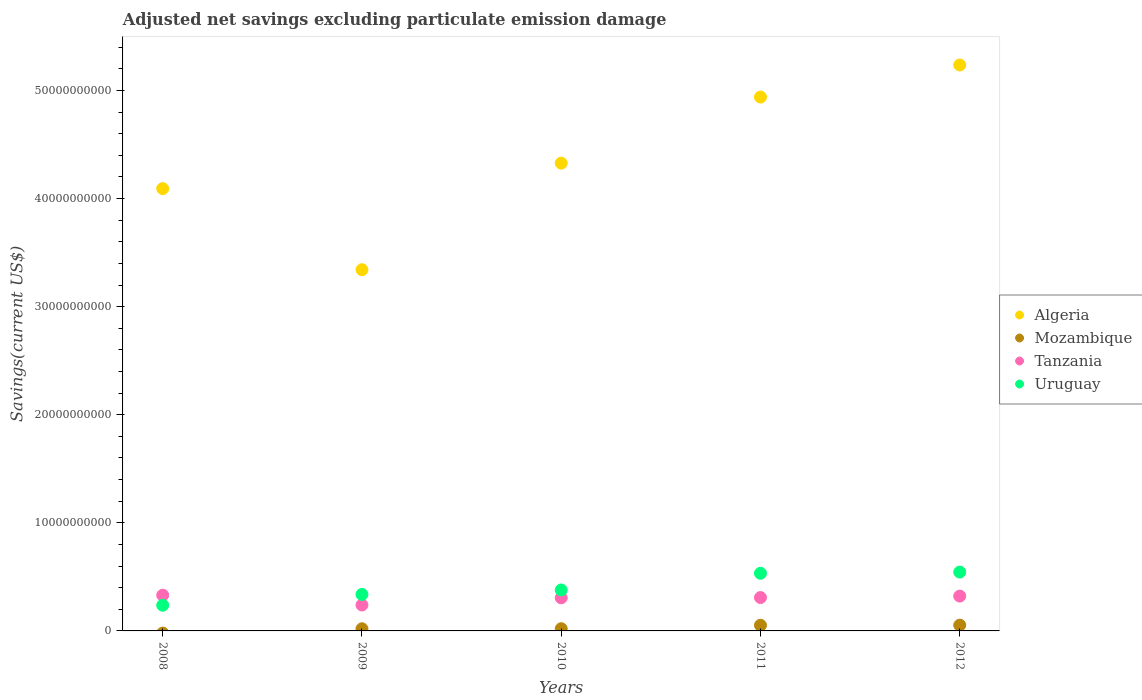Is the number of dotlines equal to the number of legend labels?
Ensure brevity in your answer.  No. What is the adjusted net savings in Tanzania in 2009?
Make the answer very short. 2.40e+09. Across all years, what is the maximum adjusted net savings in Algeria?
Offer a terse response. 5.24e+1. Across all years, what is the minimum adjusted net savings in Tanzania?
Your answer should be compact. 2.40e+09. What is the total adjusted net savings in Algeria in the graph?
Your answer should be compact. 2.19e+11. What is the difference between the adjusted net savings in Algeria in 2010 and that in 2011?
Ensure brevity in your answer.  -6.11e+09. What is the difference between the adjusted net savings in Algeria in 2011 and the adjusted net savings in Tanzania in 2012?
Provide a short and direct response. 4.62e+1. What is the average adjusted net savings in Algeria per year?
Give a very brief answer. 4.39e+1. In the year 2010, what is the difference between the adjusted net savings in Tanzania and adjusted net savings in Algeria?
Give a very brief answer. -4.02e+1. In how many years, is the adjusted net savings in Algeria greater than 38000000000 US$?
Your answer should be very brief. 4. What is the ratio of the adjusted net savings in Uruguay in 2009 to that in 2011?
Your answer should be compact. 0.63. What is the difference between the highest and the second highest adjusted net savings in Uruguay?
Your answer should be compact. 1.12e+08. What is the difference between the highest and the lowest adjusted net savings in Tanzania?
Make the answer very short. 9.09e+08. Is it the case that in every year, the sum of the adjusted net savings in Algeria and adjusted net savings in Uruguay  is greater than the adjusted net savings in Tanzania?
Your answer should be compact. Yes. Does the adjusted net savings in Uruguay monotonically increase over the years?
Give a very brief answer. Yes. Is the adjusted net savings in Tanzania strictly greater than the adjusted net savings in Algeria over the years?
Your response must be concise. No. How many dotlines are there?
Provide a short and direct response. 4. How many years are there in the graph?
Provide a short and direct response. 5. What is the difference between two consecutive major ticks on the Y-axis?
Your answer should be very brief. 1.00e+1. Does the graph contain grids?
Your answer should be compact. No. Where does the legend appear in the graph?
Provide a short and direct response. Center right. What is the title of the graph?
Your response must be concise. Adjusted net savings excluding particulate emission damage. What is the label or title of the Y-axis?
Ensure brevity in your answer.  Savings(current US$). What is the Savings(current US$) of Algeria in 2008?
Ensure brevity in your answer.  4.09e+1. What is the Savings(current US$) in Mozambique in 2008?
Keep it short and to the point. 0. What is the Savings(current US$) of Tanzania in 2008?
Offer a terse response. 3.30e+09. What is the Savings(current US$) of Uruguay in 2008?
Your answer should be very brief. 2.38e+09. What is the Savings(current US$) of Algeria in 2009?
Make the answer very short. 3.34e+1. What is the Savings(current US$) of Mozambique in 2009?
Provide a short and direct response. 1.98e+08. What is the Savings(current US$) of Tanzania in 2009?
Your answer should be very brief. 2.40e+09. What is the Savings(current US$) in Uruguay in 2009?
Make the answer very short. 3.38e+09. What is the Savings(current US$) in Algeria in 2010?
Provide a succinct answer. 4.33e+1. What is the Savings(current US$) in Mozambique in 2010?
Make the answer very short. 2.04e+08. What is the Savings(current US$) in Tanzania in 2010?
Give a very brief answer. 3.06e+09. What is the Savings(current US$) of Uruguay in 2010?
Keep it short and to the point. 3.79e+09. What is the Savings(current US$) of Algeria in 2011?
Keep it short and to the point. 4.94e+1. What is the Savings(current US$) of Mozambique in 2011?
Offer a very short reply. 5.23e+08. What is the Savings(current US$) in Tanzania in 2011?
Keep it short and to the point. 3.09e+09. What is the Savings(current US$) in Uruguay in 2011?
Your response must be concise. 5.33e+09. What is the Savings(current US$) of Algeria in 2012?
Make the answer very short. 5.24e+1. What is the Savings(current US$) of Mozambique in 2012?
Your answer should be very brief. 5.34e+08. What is the Savings(current US$) in Tanzania in 2012?
Offer a terse response. 3.22e+09. What is the Savings(current US$) of Uruguay in 2012?
Your answer should be very brief. 5.44e+09. Across all years, what is the maximum Savings(current US$) of Algeria?
Your answer should be very brief. 5.24e+1. Across all years, what is the maximum Savings(current US$) in Mozambique?
Your answer should be compact. 5.34e+08. Across all years, what is the maximum Savings(current US$) of Tanzania?
Provide a succinct answer. 3.30e+09. Across all years, what is the maximum Savings(current US$) in Uruguay?
Keep it short and to the point. 5.44e+09. Across all years, what is the minimum Savings(current US$) of Algeria?
Your answer should be compact. 3.34e+1. Across all years, what is the minimum Savings(current US$) of Mozambique?
Your answer should be compact. 0. Across all years, what is the minimum Savings(current US$) in Tanzania?
Your answer should be very brief. 2.40e+09. Across all years, what is the minimum Savings(current US$) in Uruguay?
Offer a very short reply. 2.38e+09. What is the total Savings(current US$) of Algeria in the graph?
Give a very brief answer. 2.19e+11. What is the total Savings(current US$) in Mozambique in the graph?
Your response must be concise. 1.46e+09. What is the total Savings(current US$) in Tanzania in the graph?
Your answer should be compact. 1.51e+1. What is the total Savings(current US$) of Uruguay in the graph?
Your answer should be very brief. 2.03e+1. What is the difference between the Savings(current US$) in Algeria in 2008 and that in 2009?
Keep it short and to the point. 7.50e+09. What is the difference between the Savings(current US$) in Tanzania in 2008 and that in 2009?
Offer a very short reply. 9.09e+08. What is the difference between the Savings(current US$) in Uruguay in 2008 and that in 2009?
Provide a short and direct response. -1.00e+09. What is the difference between the Savings(current US$) of Algeria in 2008 and that in 2010?
Ensure brevity in your answer.  -2.35e+09. What is the difference between the Savings(current US$) in Tanzania in 2008 and that in 2010?
Your answer should be very brief. 2.43e+08. What is the difference between the Savings(current US$) in Uruguay in 2008 and that in 2010?
Your answer should be very brief. -1.41e+09. What is the difference between the Savings(current US$) in Algeria in 2008 and that in 2011?
Provide a succinct answer. -8.47e+09. What is the difference between the Savings(current US$) of Tanzania in 2008 and that in 2011?
Keep it short and to the point. 2.18e+08. What is the difference between the Savings(current US$) of Uruguay in 2008 and that in 2011?
Offer a terse response. -2.96e+09. What is the difference between the Savings(current US$) in Algeria in 2008 and that in 2012?
Your response must be concise. -1.14e+1. What is the difference between the Savings(current US$) in Tanzania in 2008 and that in 2012?
Your answer should be compact. 8.26e+07. What is the difference between the Savings(current US$) of Uruguay in 2008 and that in 2012?
Make the answer very short. -3.07e+09. What is the difference between the Savings(current US$) of Algeria in 2009 and that in 2010?
Give a very brief answer. -9.86e+09. What is the difference between the Savings(current US$) in Mozambique in 2009 and that in 2010?
Your answer should be compact. -6.49e+06. What is the difference between the Savings(current US$) in Tanzania in 2009 and that in 2010?
Provide a succinct answer. -6.66e+08. What is the difference between the Savings(current US$) of Uruguay in 2009 and that in 2010?
Make the answer very short. -4.13e+08. What is the difference between the Savings(current US$) in Algeria in 2009 and that in 2011?
Offer a very short reply. -1.60e+1. What is the difference between the Savings(current US$) in Mozambique in 2009 and that in 2011?
Your answer should be very brief. -3.26e+08. What is the difference between the Savings(current US$) in Tanzania in 2009 and that in 2011?
Give a very brief answer. -6.91e+08. What is the difference between the Savings(current US$) of Uruguay in 2009 and that in 2011?
Offer a very short reply. -1.96e+09. What is the difference between the Savings(current US$) of Algeria in 2009 and that in 2012?
Provide a succinct answer. -1.89e+1. What is the difference between the Savings(current US$) in Mozambique in 2009 and that in 2012?
Your answer should be compact. -3.36e+08. What is the difference between the Savings(current US$) of Tanzania in 2009 and that in 2012?
Provide a short and direct response. -8.26e+08. What is the difference between the Savings(current US$) of Uruguay in 2009 and that in 2012?
Your answer should be very brief. -2.07e+09. What is the difference between the Savings(current US$) in Algeria in 2010 and that in 2011?
Offer a terse response. -6.11e+09. What is the difference between the Savings(current US$) of Mozambique in 2010 and that in 2011?
Your response must be concise. -3.19e+08. What is the difference between the Savings(current US$) of Tanzania in 2010 and that in 2011?
Offer a very short reply. -2.55e+07. What is the difference between the Savings(current US$) of Uruguay in 2010 and that in 2011?
Your answer should be compact. -1.54e+09. What is the difference between the Savings(current US$) in Algeria in 2010 and that in 2012?
Your response must be concise. -9.08e+09. What is the difference between the Savings(current US$) in Mozambique in 2010 and that in 2012?
Keep it short and to the point. -3.30e+08. What is the difference between the Savings(current US$) of Tanzania in 2010 and that in 2012?
Your response must be concise. -1.60e+08. What is the difference between the Savings(current US$) in Uruguay in 2010 and that in 2012?
Give a very brief answer. -1.65e+09. What is the difference between the Savings(current US$) in Algeria in 2011 and that in 2012?
Keep it short and to the point. -2.97e+09. What is the difference between the Savings(current US$) in Mozambique in 2011 and that in 2012?
Your answer should be compact. -1.03e+07. What is the difference between the Savings(current US$) of Tanzania in 2011 and that in 2012?
Make the answer very short. -1.35e+08. What is the difference between the Savings(current US$) of Uruguay in 2011 and that in 2012?
Offer a terse response. -1.12e+08. What is the difference between the Savings(current US$) in Algeria in 2008 and the Savings(current US$) in Mozambique in 2009?
Make the answer very short. 4.07e+1. What is the difference between the Savings(current US$) in Algeria in 2008 and the Savings(current US$) in Tanzania in 2009?
Your answer should be compact. 3.85e+1. What is the difference between the Savings(current US$) of Algeria in 2008 and the Savings(current US$) of Uruguay in 2009?
Provide a succinct answer. 3.75e+1. What is the difference between the Savings(current US$) in Tanzania in 2008 and the Savings(current US$) in Uruguay in 2009?
Make the answer very short. -7.11e+07. What is the difference between the Savings(current US$) in Algeria in 2008 and the Savings(current US$) in Mozambique in 2010?
Your answer should be very brief. 4.07e+1. What is the difference between the Savings(current US$) of Algeria in 2008 and the Savings(current US$) of Tanzania in 2010?
Make the answer very short. 3.79e+1. What is the difference between the Savings(current US$) in Algeria in 2008 and the Savings(current US$) in Uruguay in 2010?
Keep it short and to the point. 3.71e+1. What is the difference between the Savings(current US$) of Tanzania in 2008 and the Savings(current US$) of Uruguay in 2010?
Keep it short and to the point. -4.84e+08. What is the difference between the Savings(current US$) of Algeria in 2008 and the Savings(current US$) of Mozambique in 2011?
Offer a very short reply. 4.04e+1. What is the difference between the Savings(current US$) in Algeria in 2008 and the Savings(current US$) in Tanzania in 2011?
Make the answer very short. 3.78e+1. What is the difference between the Savings(current US$) of Algeria in 2008 and the Savings(current US$) of Uruguay in 2011?
Keep it short and to the point. 3.56e+1. What is the difference between the Savings(current US$) in Tanzania in 2008 and the Savings(current US$) in Uruguay in 2011?
Offer a terse response. -2.03e+09. What is the difference between the Savings(current US$) of Algeria in 2008 and the Savings(current US$) of Mozambique in 2012?
Your response must be concise. 4.04e+1. What is the difference between the Savings(current US$) of Algeria in 2008 and the Savings(current US$) of Tanzania in 2012?
Keep it short and to the point. 3.77e+1. What is the difference between the Savings(current US$) in Algeria in 2008 and the Savings(current US$) in Uruguay in 2012?
Offer a terse response. 3.55e+1. What is the difference between the Savings(current US$) of Tanzania in 2008 and the Savings(current US$) of Uruguay in 2012?
Offer a very short reply. -2.14e+09. What is the difference between the Savings(current US$) of Algeria in 2009 and the Savings(current US$) of Mozambique in 2010?
Ensure brevity in your answer.  3.32e+1. What is the difference between the Savings(current US$) in Algeria in 2009 and the Savings(current US$) in Tanzania in 2010?
Offer a very short reply. 3.04e+1. What is the difference between the Savings(current US$) in Algeria in 2009 and the Savings(current US$) in Uruguay in 2010?
Your answer should be compact. 2.96e+1. What is the difference between the Savings(current US$) of Mozambique in 2009 and the Savings(current US$) of Tanzania in 2010?
Make the answer very short. -2.86e+09. What is the difference between the Savings(current US$) in Mozambique in 2009 and the Savings(current US$) in Uruguay in 2010?
Provide a short and direct response. -3.59e+09. What is the difference between the Savings(current US$) of Tanzania in 2009 and the Savings(current US$) of Uruguay in 2010?
Your answer should be very brief. -1.39e+09. What is the difference between the Savings(current US$) of Algeria in 2009 and the Savings(current US$) of Mozambique in 2011?
Offer a very short reply. 3.29e+1. What is the difference between the Savings(current US$) of Algeria in 2009 and the Savings(current US$) of Tanzania in 2011?
Offer a terse response. 3.03e+1. What is the difference between the Savings(current US$) of Algeria in 2009 and the Savings(current US$) of Uruguay in 2011?
Ensure brevity in your answer.  2.81e+1. What is the difference between the Savings(current US$) in Mozambique in 2009 and the Savings(current US$) in Tanzania in 2011?
Provide a short and direct response. -2.89e+09. What is the difference between the Savings(current US$) in Mozambique in 2009 and the Savings(current US$) in Uruguay in 2011?
Offer a terse response. -5.13e+09. What is the difference between the Savings(current US$) in Tanzania in 2009 and the Savings(current US$) in Uruguay in 2011?
Make the answer very short. -2.94e+09. What is the difference between the Savings(current US$) of Algeria in 2009 and the Savings(current US$) of Mozambique in 2012?
Provide a succinct answer. 3.29e+1. What is the difference between the Savings(current US$) in Algeria in 2009 and the Savings(current US$) in Tanzania in 2012?
Ensure brevity in your answer.  3.02e+1. What is the difference between the Savings(current US$) in Algeria in 2009 and the Savings(current US$) in Uruguay in 2012?
Your response must be concise. 2.80e+1. What is the difference between the Savings(current US$) in Mozambique in 2009 and the Savings(current US$) in Tanzania in 2012?
Your response must be concise. -3.02e+09. What is the difference between the Savings(current US$) in Mozambique in 2009 and the Savings(current US$) in Uruguay in 2012?
Your answer should be compact. -5.25e+09. What is the difference between the Savings(current US$) in Tanzania in 2009 and the Savings(current US$) in Uruguay in 2012?
Ensure brevity in your answer.  -3.05e+09. What is the difference between the Savings(current US$) of Algeria in 2010 and the Savings(current US$) of Mozambique in 2011?
Provide a succinct answer. 4.28e+1. What is the difference between the Savings(current US$) in Algeria in 2010 and the Savings(current US$) in Tanzania in 2011?
Keep it short and to the point. 4.02e+1. What is the difference between the Savings(current US$) in Algeria in 2010 and the Savings(current US$) in Uruguay in 2011?
Offer a terse response. 3.79e+1. What is the difference between the Savings(current US$) in Mozambique in 2010 and the Savings(current US$) in Tanzania in 2011?
Keep it short and to the point. -2.88e+09. What is the difference between the Savings(current US$) in Mozambique in 2010 and the Savings(current US$) in Uruguay in 2011?
Keep it short and to the point. -5.13e+09. What is the difference between the Savings(current US$) in Tanzania in 2010 and the Savings(current US$) in Uruguay in 2011?
Keep it short and to the point. -2.27e+09. What is the difference between the Savings(current US$) of Algeria in 2010 and the Savings(current US$) of Mozambique in 2012?
Make the answer very short. 4.27e+1. What is the difference between the Savings(current US$) of Algeria in 2010 and the Savings(current US$) of Tanzania in 2012?
Provide a succinct answer. 4.01e+1. What is the difference between the Savings(current US$) in Algeria in 2010 and the Savings(current US$) in Uruguay in 2012?
Your response must be concise. 3.78e+1. What is the difference between the Savings(current US$) in Mozambique in 2010 and the Savings(current US$) in Tanzania in 2012?
Keep it short and to the point. -3.02e+09. What is the difference between the Savings(current US$) in Mozambique in 2010 and the Savings(current US$) in Uruguay in 2012?
Your answer should be compact. -5.24e+09. What is the difference between the Savings(current US$) of Tanzania in 2010 and the Savings(current US$) of Uruguay in 2012?
Offer a terse response. -2.38e+09. What is the difference between the Savings(current US$) in Algeria in 2011 and the Savings(current US$) in Mozambique in 2012?
Your answer should be compact. 4.89e+1. What is the difference between the Savings(current US$) in Algeria in 2011 and the Savings(current US$) in Tanzania in 2012?
Provide a short and direct response. 4.62e+1. What is the difference between the Savings(current US$) in Algeria in 2011 and the Savings(current US$) in Uruguay in 2012?
Ensure brevity in your answer.  4.39e+1. What is the difference between the Savings(current US$) of Mozambique in 2011 and the Savings(current US$) of Tanzania in 2012?
Ensure brevity in your answer.  -2.70e+09. What is the difference between the Savings(current US$) of Mozambique in 2011 and the Savings(current US$) of Uruguay in 2012?
Provide a succinct answer. -4.92e+09. What is the difference between the Savings(current US$) in Tanzania in 2011 and the Savings(current US$) in Uruguay in 2012?
Your answer should be very brief. -2.36e+09. What is the average Savings(current US$) in Algeria per year?
Give a very brief answer. 4.39e+1. What is the average Savings(current US$) of Mozambique per year?
Provide a short and direct response. 2.92e+08. What is the average Savings(current US$) of Tanzania per year?
Give a very brief answer. 3.01e+09. What is the average Savings(current US$) in Uruguay per year?
Give a very brief answer. 4.06e+09. In the year 2008, what is the difference between the Savings(current US$) of Algeria and Savings(current US$) of Tanzania?
Your answer should be very brief. 3.76e+1. In the year 2008, what is the difference between the Savings(current US$) in Algeria and Savings(current US$) in Uruguay?
Give a very brief answer. 3.85e+1. In the year 2008, what is the difference between the Savings(current US$) of Tanzania and Savings(current US$) of Uruguay?
Make the answer very short. 9.29e+08. In the year 2009, what is the difference between the Savings(current US$) in Algeria and Savings(current US$) in Mozambique?
Make the answer very short. 3.32e+1. In the year 2009, what is the difference between the Savings(current US$) in Algeria and Savings(current US$) in Tanzania?
Provide a short and direct response. 3.10e+1. In the year 2009, what is the difference between the Savings(current US$) in Algeria and Savings(current US$) in Uruguay?
Keep it short and to the point. 3.00e+1. In the year 2009, what is the difference between the Savings(current US$) of Mozambique and Savings(current US$) of Tanzania?
Keep it short and to the point. -2.20e+09. In the year 2009, what is the difference between the Savings(current US$) of Mozambique and Savings(current US$) of Uruguay?
Provide a short and direct response. -3.18e+09. In the year 2009, what is the difference between the Savings(current US$) of Tanzania and Savings(current US$) of Uruguay?
Ensure brevity in your answer.  -9.80e+08. In the year 2010, what is the difference between the Savings(current US$) in Algeria and Savings(current US$) in Mozambique?
Your answer should be compact. 4.31e+1. In the year 2010, what is the difference between the Savings(current US$) of Algeria and Savings(current US$) of Tanzania?
Your answer should be compact. 4.02e+1. In the year 2010, what is the difference between the Savings(current US$) of Algeria and Savings(current US$) of Uruguay?
Offer a terse response. 3.95e+1. In the year 2010, what is the difference between the Savings(current US$) of Mozambique and Savings(current US$) of Tanzania?
Your response must be concise. -2.86e+09. In the year 2010, what is the difference between the Savings(current US$) of Mozambique and Savings(current US$) of Uruguay?
Your response must be concise. -3.59e+09. In the year 2010, what is the difference between the Savings(current US$) in Tanzania and Savings(current US$) in Uruguay?
Keep it short and to the point. -7.28e+08. In the year 2011, what is the difference between the Savings(current US$) of Algeria and Savings(current US$) of Mozambique?
Your answer should be very brief. 4.89e+1. In the year 2011, what is the difference between the Savings(current US$) of Algeria and Savings(current US$) of Tanzania?
Make the answer very short. 4.63e+1. In the year 2011, what is the difference between the Savings(current US$) of Algeria and Savings(current US$) of Uruguay?
Give a very brief answer. 4.41e+1. In the year 2011, what is the difference between the Savings(current US$) of Mozambique and Savings(current US$) of Tanzania?
Provide a succinct answer. -2.56e+09. In the year 2011, what is the difference between the Savings(current US$) in Mozambique and Savings(current US$) in Uruguay?
Your response must be concise. -4.81e+09. In the year 2011, what is the difference between the Savings(current US$) of Tanzania and Savings(current US$) of Uruguay?
Ensure brevity in your answer.  -2.25e+09. In the year 2012, what is the difference between the Savings(current US$) of Algeria and Savings(current US$) of Mozambique?
Give a very brief answer. 5.18e+1. In the year 2012, what is the difference between the Savings(current US$) in Algeria and Savings(current US$) in Tanzania?
Keep it short and to the point. 4.91e+1. In the year 2012, what is the difference between the Savings(current US$) of Algeria and Savings(current US$) of Uruguay?
Offer a very short reply. 4.69e+1. In the year 2012, what is the difference between the Savings(current US$) of Mozambique and Savings(current US$) of Tanzania?
Keep it short and to the point. -2.69e+09. In the year 2012, what is the difference between the Savings(current US$) in Mozambique and Savings(current US$) in Uruguay?
Your answer should be very brief. -4.91e+09. In the year 2012, what is the difference between the Savings(current US$) in Tanzania and Savings(current US$) in Uruguay?
Provide a succinct answer. -2.22e+09. What is the ratio of the Savings(current US$) of Algeria in 2008 to that in 2009?
Provide a short and direct response. 1.22. What is the ratio of the Savings(current US$) in Tanzania in 2008 to that in 2009?
Make the answer very short. 1.38. What is the ratio of the Savings(current US$) in Uruguay in 2008 to that in 2009?
Make the answer very short. 0.7. What is the ratio of the Savings(current US$) in Algeria in 2008 to that in 2010?
Your response must be concise. 0.95. What is the ratio of the Savings(current US$) in Tanzania in 2008 to that in 2010?
Provide a short and direct response. 1.08. What is the ratio of the Savings(current US$) of Uruguay in 2008 to that in 2010?
Provide a short and direct response. 0.63. What is the ratio of the Savings(current US$) of Algeria in 2008 to that in 2011?
Provide a succinct answer. 0.83. What is the ratio of the Savings(current US$) in Tanzania in 2008 to that in 2011?
Provide a short and direct response. 1.07. What is the ratio of the Savings(current US$) of Uruguay in 2008 to that in 2011?
Make the answer very short. 0.45. What is the ratio of the Savings(current US$) in Algeria in 2008 to that in 2012?
Your answer should be very brief. 0.78. What is the ratio of the Savings(current US$) of Tanzania in 2008 to that in 2012?
Give a very brief answer. 1.03. What is the ratio of the Savings(current US$) of Uruguay in 2008 to that in 2012?
Make the answer very short. 0.44. What is the ratio of the Savings(current US$) in Algeria in 2009 to that in 2010?
Your response must be concise. 0.77. What is the ratio of the Savings(current US$) in Mozambique in 2009 to that in 2010?
Ensure brevity in your answer.  0.97. What is the ratio of the Savings(current US$) of Tanzania in 2009 to that in 2010?
Your response must be concise. 0.78. What is the ratio of the Savings(current US$) of Uruguay in 2009 to that in 2010?
Ensure brevity in your answer.  0.89. What is the ratio of the Savings(current US$) of Algeria in 2009 to that in 2011?
Provide a short and direct response. 0.68. What is the ratio of the Savings(current US$) of Mozambique in 2009 to that in 2011?
Your answer should be very brief. 0.38. What is the ratio of the Savings(current US$) of Tanzania in 2009 to that in 2011?
Ensure brevity in your answer.  0.78. What is the ratio of the Savings(current US$) of Uruguay in 2009 to that in 2011?
Your response must be concise. 0.63. What is the ratio of the Savings(current US$) in Algeria in 2009 to that in 2012?
Your answer should be compact. 0.64. What is the ratio of the Savings(current US$) of Mozambique in 2009 to that in 2012?
Your answer should be very brief. 0.37. What is the ratio of the Savings(current US$) in Tanzania in 2009 to that in 2012?
Ensure brevity in your answer.  0.74. What is the ratio of the Savings(current US$) of Uruguay in 2009 to that in 2012?
Offer a very short reply. 0.62. What is the ratio of the Savings(current US$) in Algeria in 2010 to that in 2011?
Give a very brief answer. 0.88. What is the ratio of the Savings(current US$) of Mozambique in 2010 to that in 2011?
Your answer should be compact. 0.39. What is the ratio of the Savings(current US$) in Tanzania in 2010 to that in 2011?
Make the answer very short. 0.99. What is the ratio of the Savings(current US$) of Uruguay in 2010 to that in 2011?
Provide a succinct answer. 0.71. What is the ratio of the Savings(current US$) of Algeria in 2010 to that in 2012?
Offer a very short reply. 0.83. What is the ratio of the Savings(current US$) in Mozambique in 2010 to that in 2012?
Offer a terse response. 0.38. What is the ratio of the Savings(current US$) of Tanzania in 2010 to that in 2012?
Your answer should be compact. 0.95. What is the ratio of the Savings(current US$) in Uruguay in 2010 to that in 2012?
Make the answer very short. 0.7. What is the ratio of the Savings(current US$) in Algeria in 2011 to that in 2012?
Make the answer very short. 0.94. What is the ratio of the Savings(current US$) in Mozambique in 2011 to that in 2012?
Ensure brevity in your answer.  0.98. What is the ratio of the Savings(current US$) in Tanzania in 2011 to that in 2012?
Provide a succinct answer. 0.96. What is the ratio of the Savings(current US$) in Uruguay in 2011 to that in 2012?
Keep it short and to the point. 0.98. What is the difference between the highest and the second highest Savings(current US$) of Algeria?
Provide a succinct answer. 2.97e+09. What is the difference between the highest and the second highest Savings(current US$) of Mozambique?
Make the answer very short. 1.03e+07. What is the difference between the highest and the second highest Savings(current US$) in Tanzania?
Provide a short and direct response. 8.26e+07. What is the difference between the highest and the second highest Savings(current US$) in Uruguay?
Provide a succinct answer. 1.12e+08. What is the difference between the highest and the lowest Savings(current US$) of Algeria?
Offer a terse response. 1.89e+1. What is the difference between the highest and the lowest Savings(current US$) in Mozambique?
Your response must be concise. 5.34e+08. What is the difference between the highest and the lowest Savings(current US$) in Tanzania?
Offer a very short reply. 9.09e+08. What is the difference between the highest and the lowest Savings(current US$) of Uruguay?
Ensure brevity in your answer.  3.07e+09. 